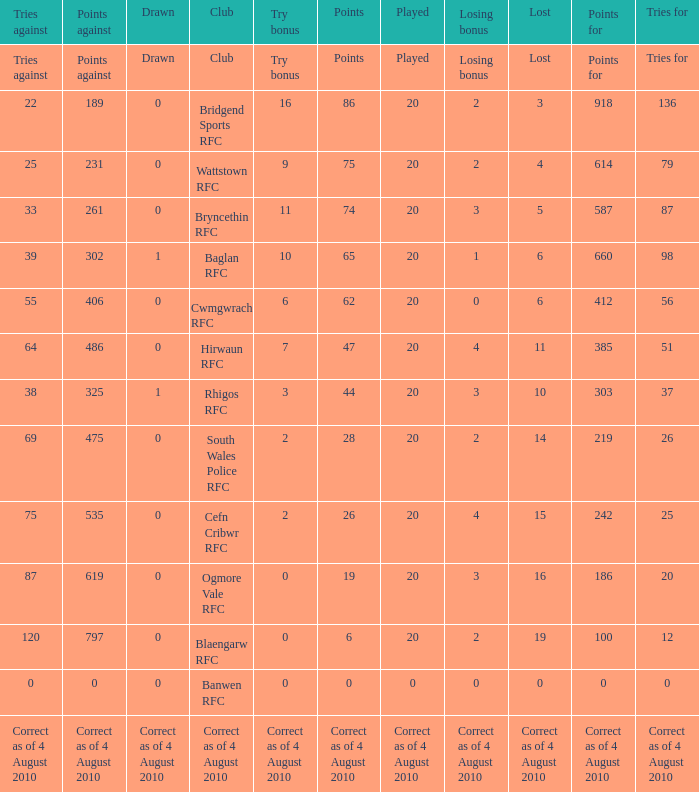What is the points when the club blaengarw rfc? 6.0. 